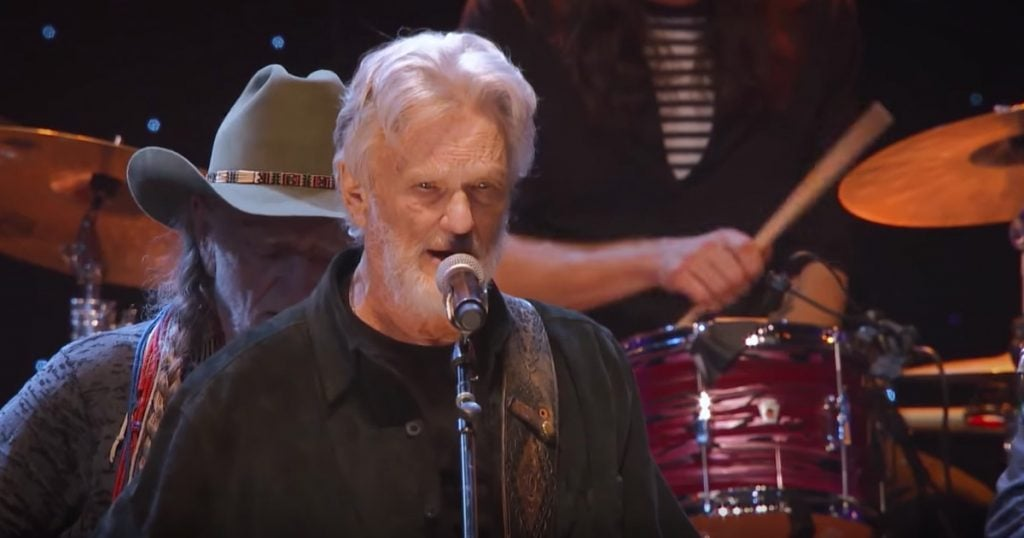Considering the attire and instruments present in the image, what genre of music are the musicians likely performing, and how does the stage setup contribute to the ambiance of their performance? The musicians are likely performing a genre of music that includes traditional, classic, or roots styles such as country, folk, or southern rock. This inference comes from the attire of the musicians: the hat worn by the singer, a common accessory in country and western styles, and the presence of a guitar and drums, which are staple instruments in these genres. The drummer's hat reinforces this traditional style. The stage setup, which features intimate lighting and a close focus on the performers, helps create a warm and cozy atmosphere. This setup is designed to foster a personal connection between the artists and the audience, enhancing the emotional impact typical of live performances in these music genres. 